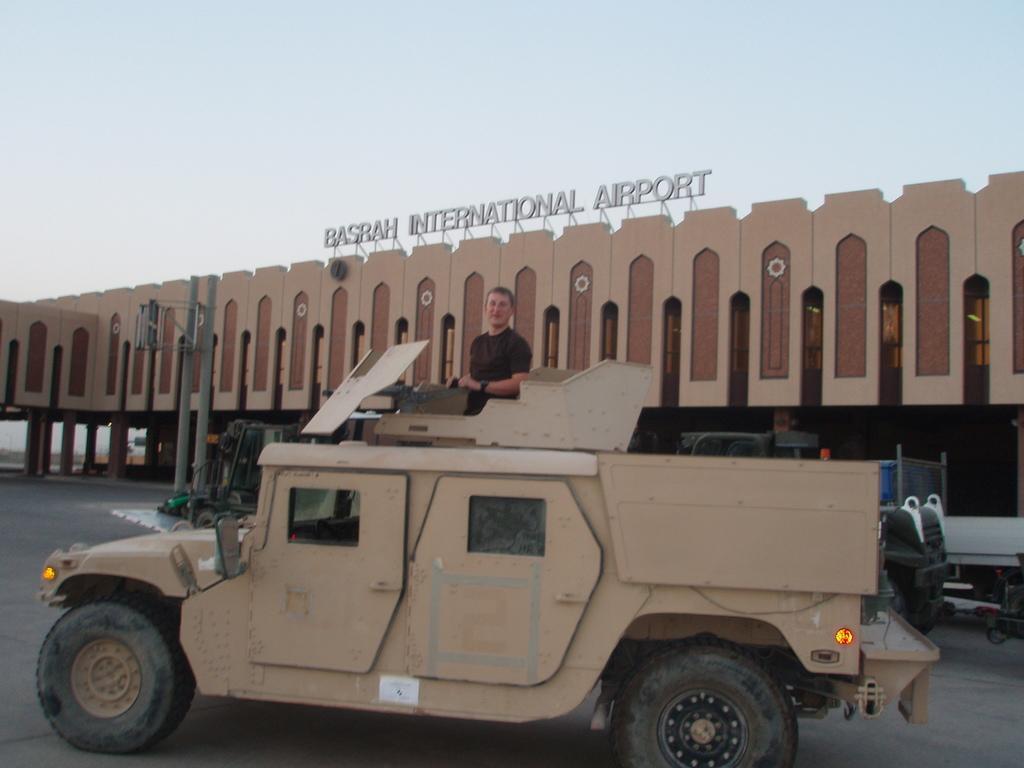Could you give a brief overview of what you see in this image? In this image we can see a vehicle and there is a person standing on the vehicle and posing for a photo. In the background of the image we can see the building with some text and at the top we can see the sky. 